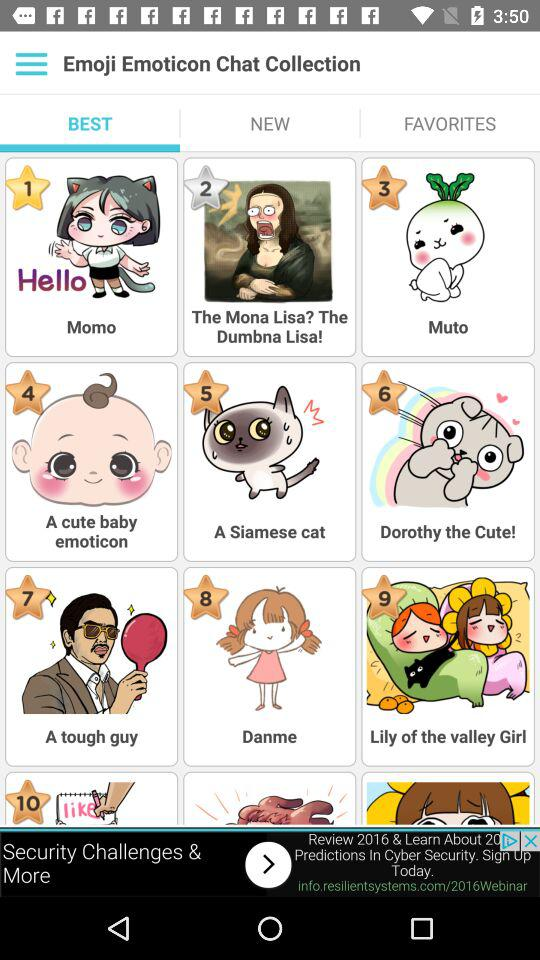Which tab is selected? The selected tab is "BEST". 